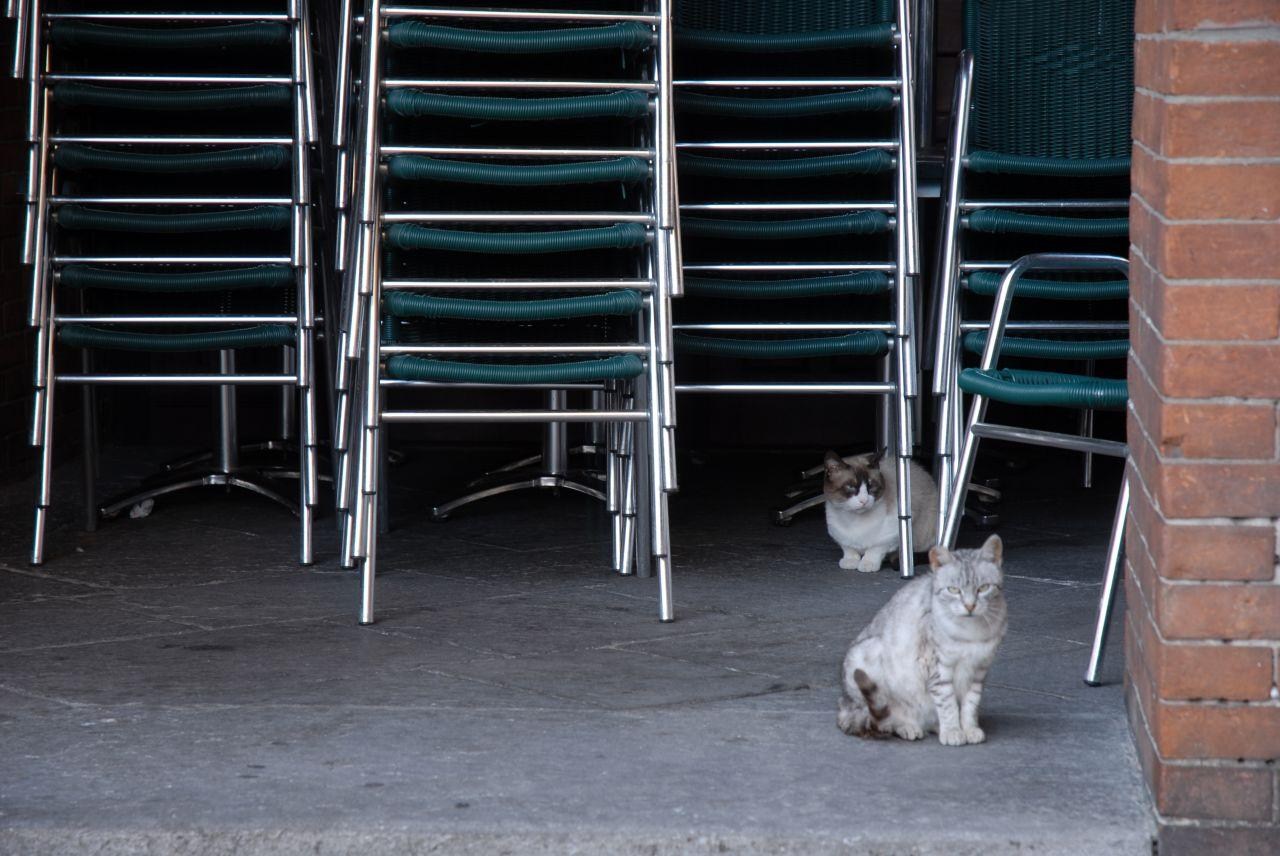Identify the primary item or items in the photograph and their main action or state. Stacks of green chairs are arranged in the room, while a gray and white cat sits on the concrete floor, and a brown and white cat appears ready to pounce. Describe the focal objects and any animals in the image, and their actions or interactions. The focal objects are the green chairs stacked in groups, while a grey and white cat sits calmly on concrete, and a brown and white cat appears poised to attack or play. Identify and describe the main subjects in this image, as well as their current activities or positions. The main subjects are the stacks of green fabric and metal chairs, a grey and white cat sitting on the concrete floor, and a brown and white cat in a state of readiness to pounce. Can you elucidate the main objects in the image, along with any unique characteristics or positions? There are several stacks of green chairs, a grey and white cat sitting on the concrete, a brown and white cat ready to pounce, and a red brick doorway in the corner. Analyze the contents of the image and provide a summary of the main components and any animals' activities. The image contains green chairs arranged in stacks, a grey and white cat sitting peacefully on concrete, and a brown and white cat appearing ready to leap, possibly to play or hunt. What are the primary elements in the picture, and what actions are being depicted? The main elements are stacks of green chairs, a grey and white cat sitting on the concrete, and a brown and white cat preparing to pounce. Examine the photograph and describe its primary subjects and any actions or occurrences involving these subjects. The photograph displays stacks of green chairs, a grey and white cat sitting idly on the concrete, and a brown and white cat with a dark mask seeming poised to pounce. What are the most distinctive components of this image, and describe any peculiarities of their appearance. The noteworthy components are the stacks of green chairs with chrome legs, a grey and white cat sitting on a gray concrete floor, and a brown and white cat with a dark mask preparing to leap. What are the prominent elements in the image, and are there any animals involved? If so, describe their actions or interactions. The prominent elements include stacks of green chairs, a grey and white cat sitting on a concrete floor, and a brown and white cat appearing ready to pounce, possibly in a playful or hunting manner. What are the key objects in the picture, and are there any creatures present? If so, what are they doing? The key objects are stacks of green chairs, a red brick doorway, a grey and white cat sitting on concrete, and a brown and white cat preparing to pounce. Is there a penguin waddling across the grey sidewalk with cracks? No, it's not mentioned in the image. 